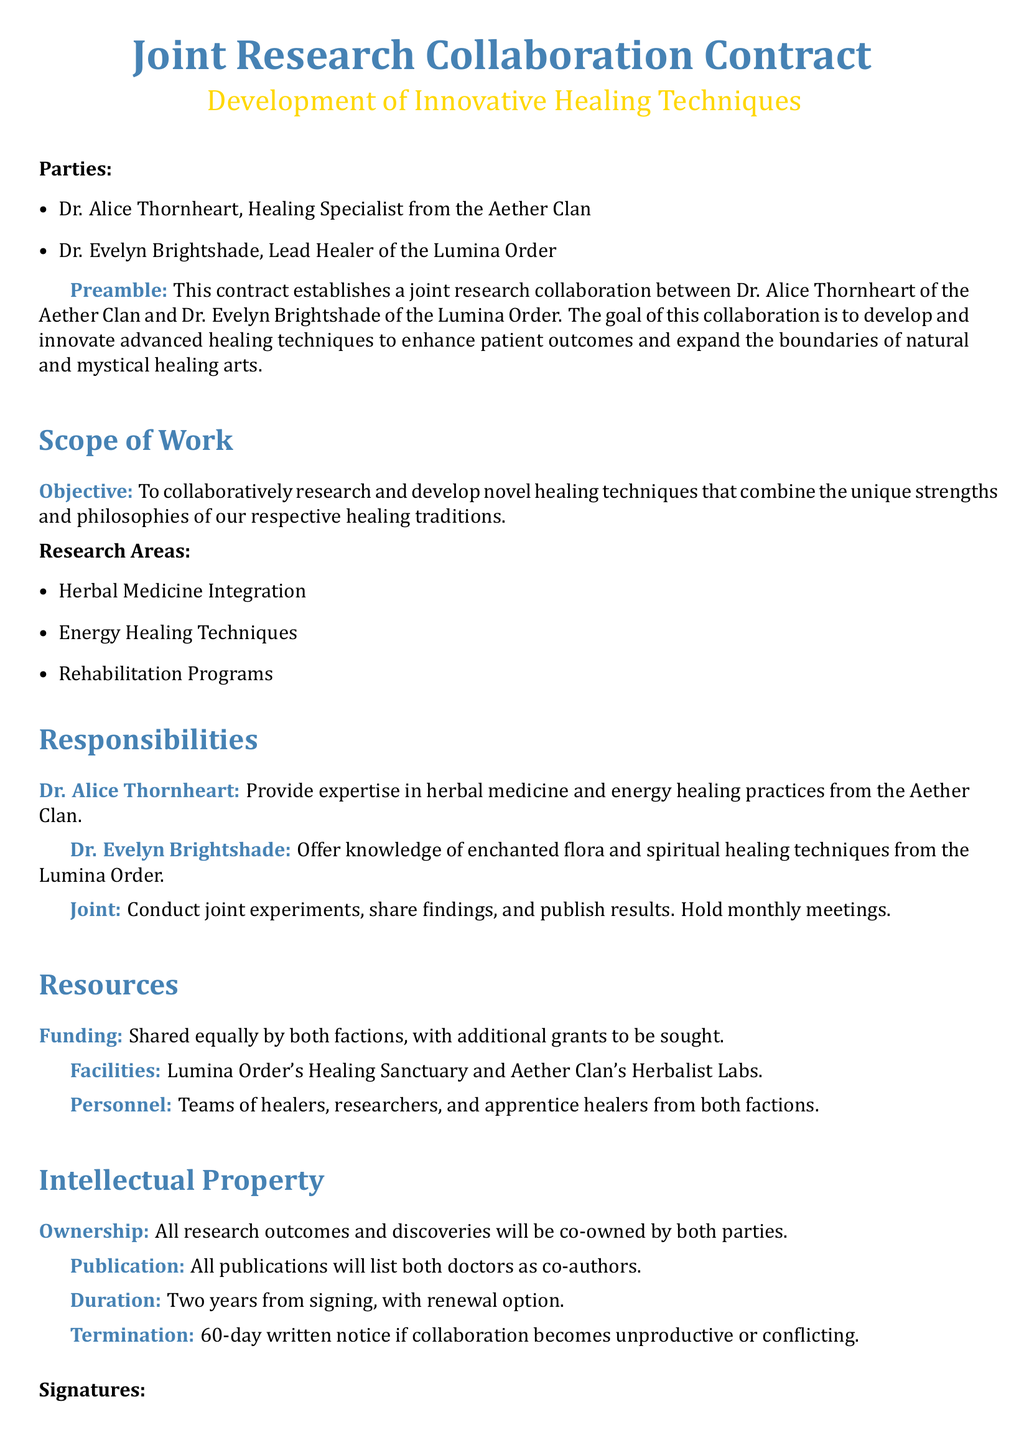What is the title of the contract? The title of the contract is highlighted at the top of the document.
Answer: Joint Research Collaboration Contract Who are the parties involved in the collaboration? The document lists the names of the two parties involved.
Answer: Dr. Alice Thornheart, Dr. Evelyn Brightshade What is the duration of the contract? The document specifies how long the collaboration will last.
Answer: Two years What are the research areas mentioned? The document lists specific areas of research under the scope of work.
Answer: Herbal Medicine Integration, Energy Healing Techniques, Rehabilitation Programs What is the shared responsibility between the two doctors? The responsibilities related to collaboration are mentioned in the document.
Answer: Conduct joint experiments, share findings, and publish results How will the funding be handled? The document describes how the funding for the project will be arranged.
Answer: Shared equally by both factions What will happen if the collaboration becomes unproductive? The document outlines the termination process if the collaboration is not effective.
Answer: 60-day written notice What type of expertise will Dr. Alice Thornheart provide? The document outlines the contributions each doctor will make.
Answer: Expertise in herbal medicine and energy healing practices Who is responsible for spiritual healing techniques? This responsibility is explicitly assigned in the document.
Answer: Dr. Evelyn Brightshade 